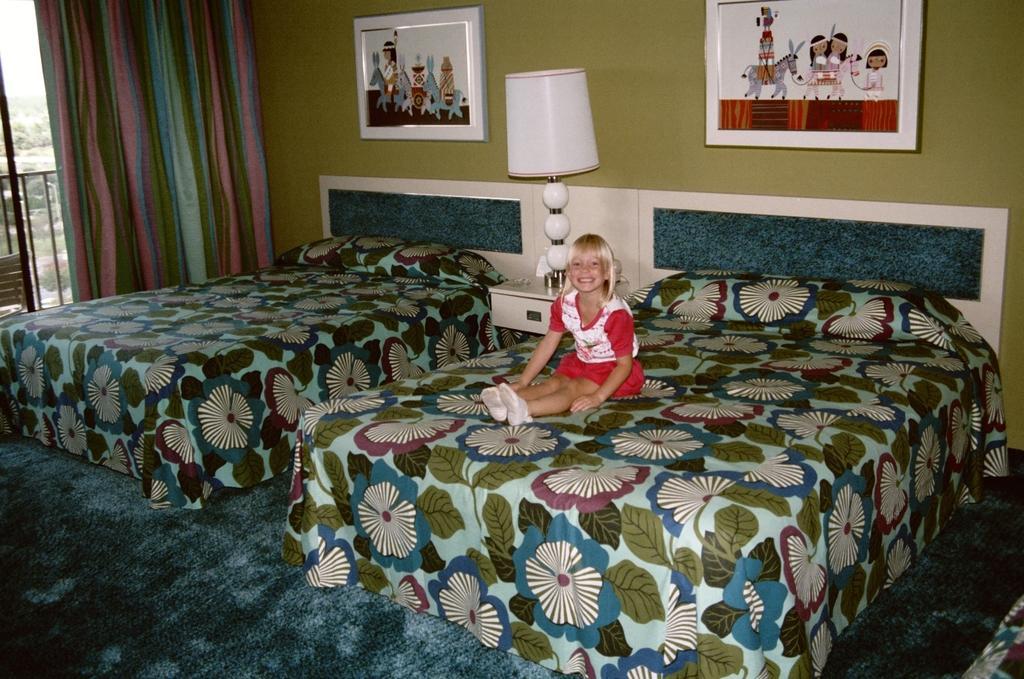Please provide a concise description of this image. A girl is sitting on the bed there is a lamp at here and photo frames on the wall. 